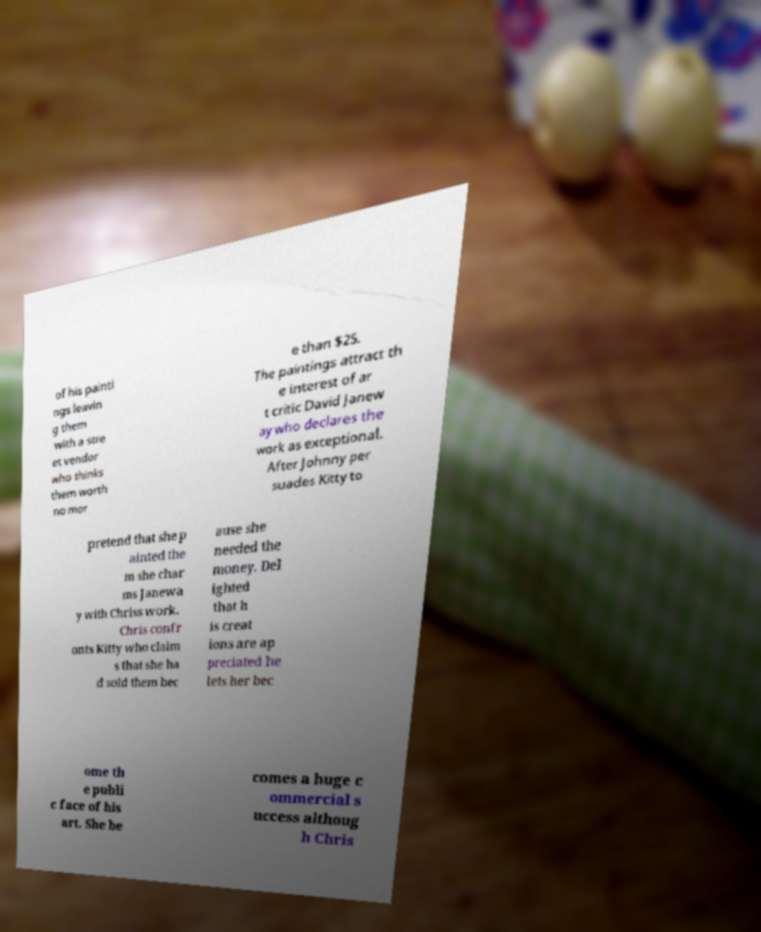There's text embedded in this image that I need extracted. Can you transcribe it verbatim? of his painti ngs leavin g them with a stre et vendor who thinks them worth no mor e than $25. The paintings attract th e interest of ar t critic David Janew ay who declares the work as exceptional. After Johnny per suades Kitty to pretend that she p ainted the m she char ms Janewa y with Chriss work. Chris confr onts Kitty who claim s that she ha d sold them bec ause she needed the money. Del ighted that h is creat ions are ap preciated he lets her bec ome th e publi c face of his art. She be comes a huge c ommercial s uccess althoug h Chris 